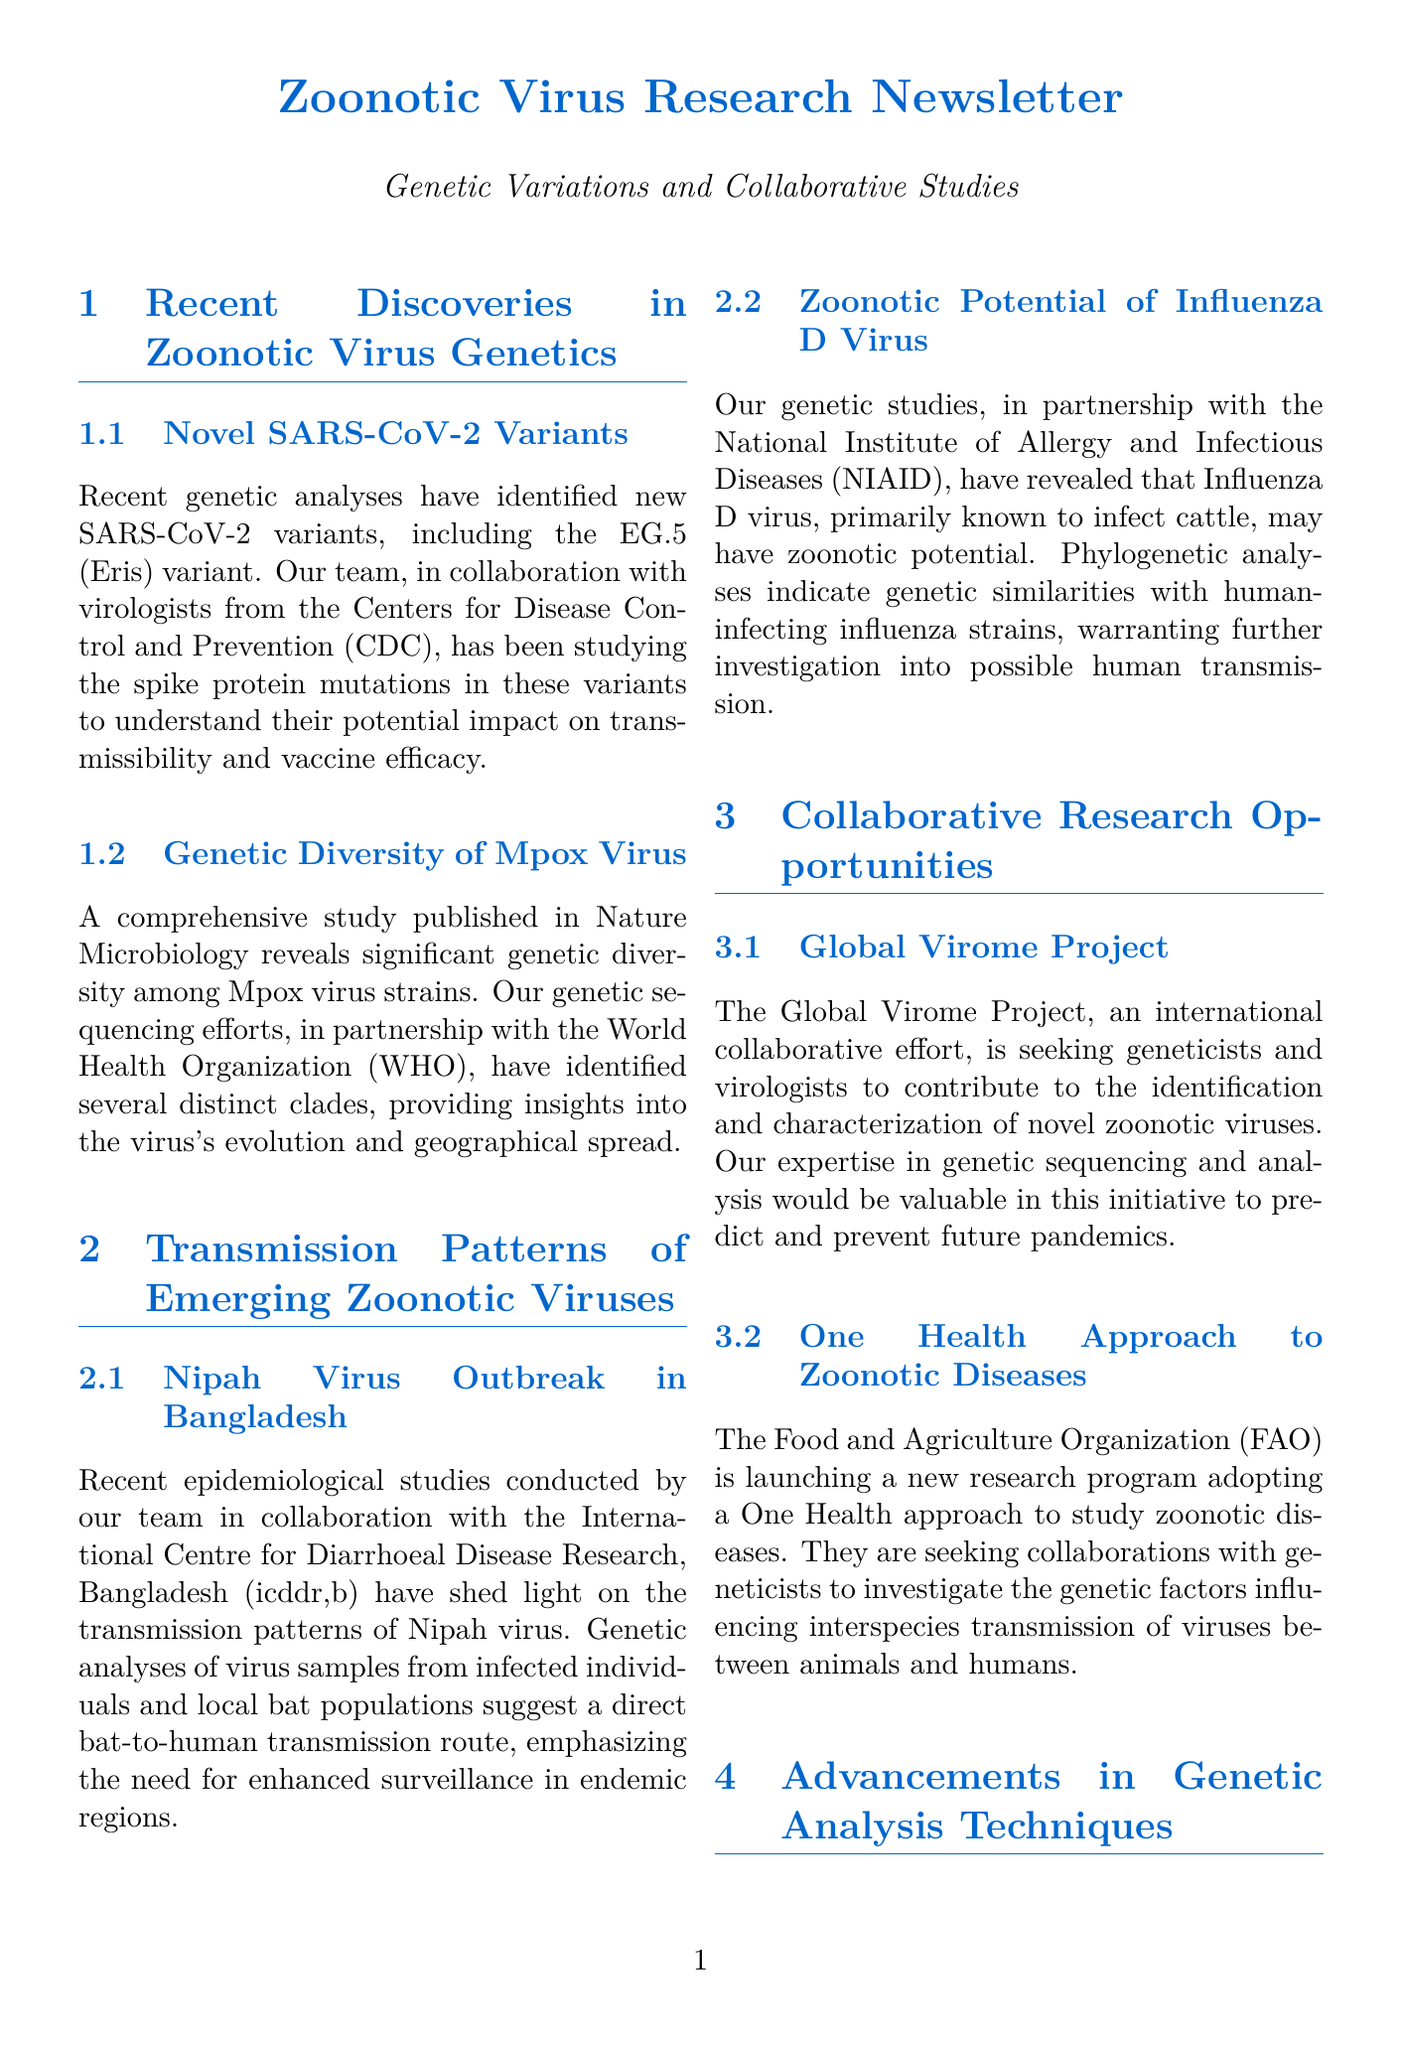What is the novel SARS-CoV-2 variant mentioned? The document states that the novel SARS-CoV-2 variant identified is EG.5 (Eris).
Answer: EG.5 (Eris) Which organization collaborated on the genetic diversity study of Mpox virus? The study on genetic diversity of Mpox virus was conducted in partnership with the World Health Organization (WHO).
Answer: World Health Organization (WHO) What virus has a potential transmission route from bats to humans? The Nipah virus has been studied for its transmission patterns that suggest a direct bat-to-human transmission route.
Answer: Nipah virus What research program is launching a One Health approach? The Food and Agriculture Organization (FAO) is launching a new research program adopting a One Health approach.
Answer: Food and Agriculture Organization (FAO) Which advanced technique is used for detailed analysis of host-pathogen interactions? The document mentions the use of single-cell RNA sequencing as a technique for analyzing host-pathogen interactions.
Answer: single-cell RNA sequencing What virus primarily infects cattle and may have zoonotic potential? The Influenza D virus is primarily known to infect cattle and may have zoonotic potential.
Answer: Influenza D virus Who is seeking researchers for the Global Virome Project? The Global Virome Project is seeking geneticists and virologists to contribute to its efforts.
Answer: geneticists and virologists What type of collaborations are being sought in the One Health approach? Collaborations are being sought to investigate the genetic factors influencing interspecies transmission of viruses.
Answer: genetic factors influencing interspecies transmission 